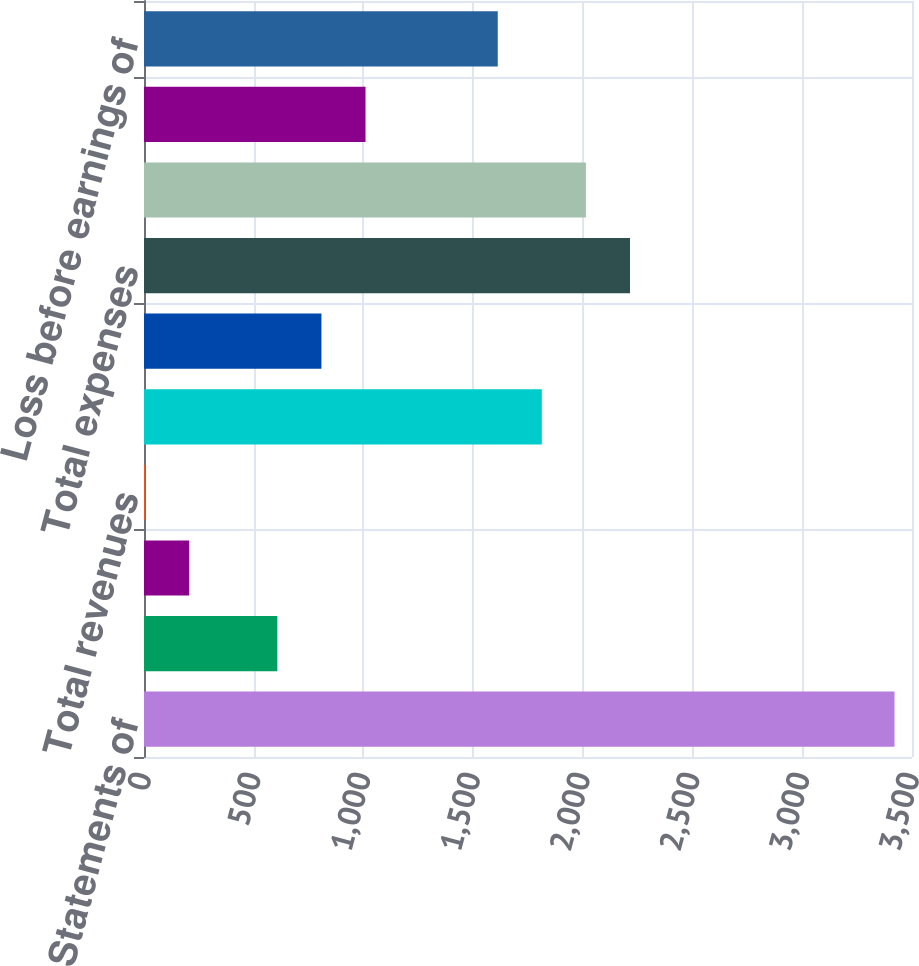Convert chart. <chart><loc_0><loc_0><loc_500><loc_500><bar_chart><fcel>Condensed Statements of<fcel>Net investment income<fcel>Net realized capital losses<fcel>Total revenues<fcel>Interest expense<fcel>Other expenses<fcel>Total expenses<fcel>Loss before income taxes and<fcel>Income tax benefit<fcel>Loss before earnings of<nl><fcel>3420.3<fcel>607.7<fcel>205.9<fcel>5<fcel>1813.1<fcel>808.6<fcel>2214.9<fcel>2014<fcel>1009.5<fcel>1612.2<nl></chart> 